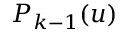Convert formula to latex. <formula><loc_0><loc_0><loc_500><loc_500>P _ { k - 1 } ( u )</formula> 